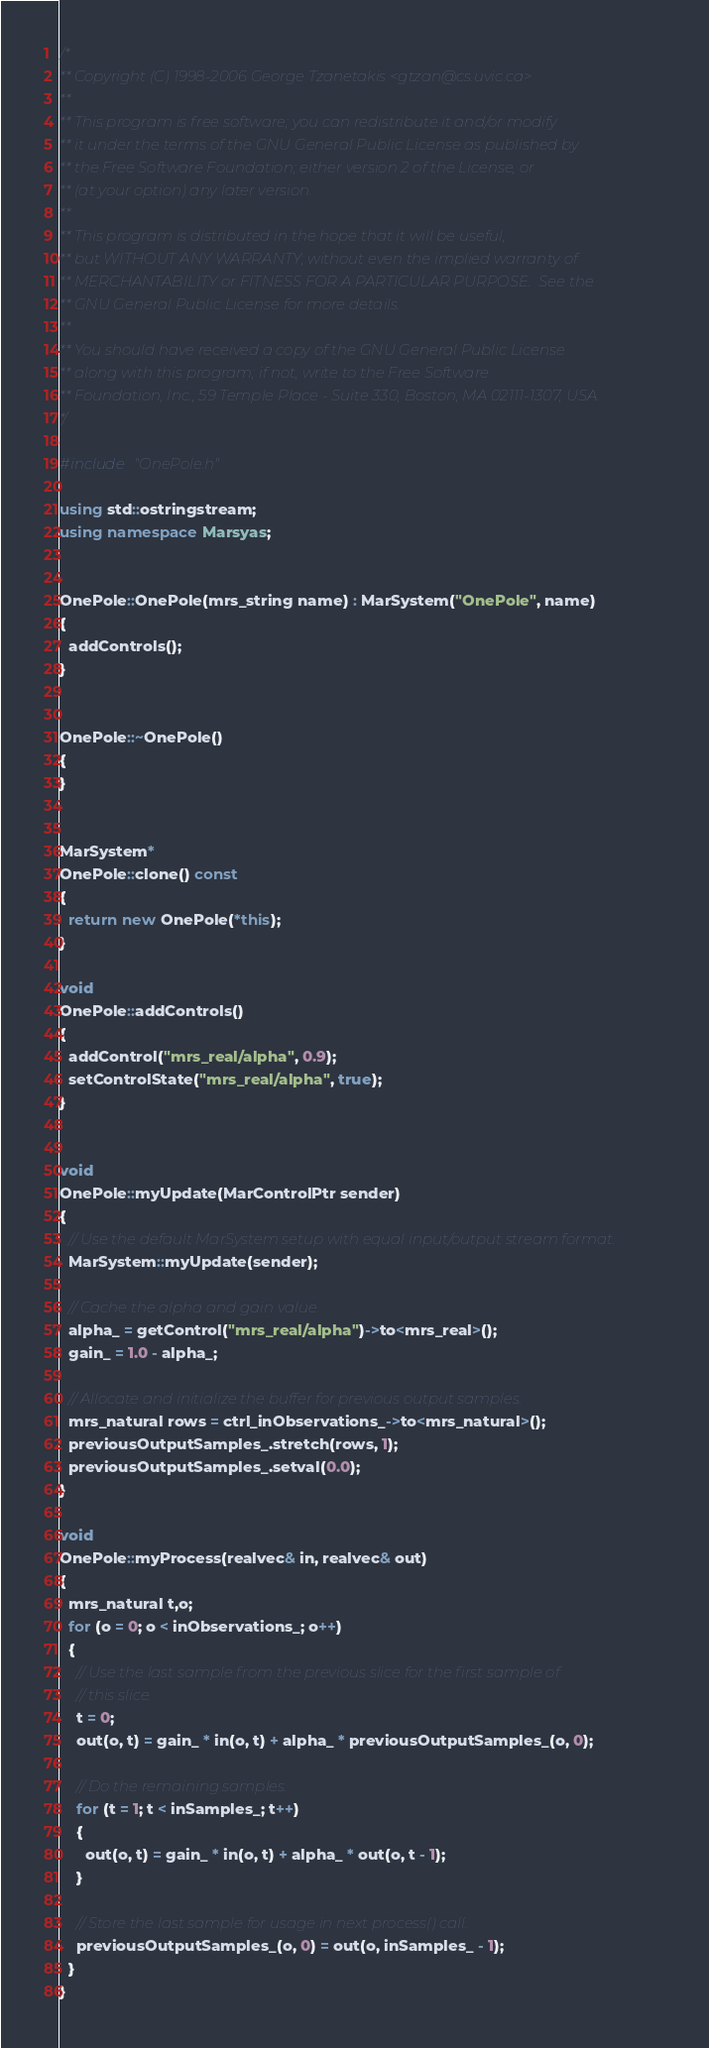<code> <loc_0><loc_0><loc_500><loc_500><_C++_>/*
** Copyright (C) 1998-2006 George Tzanetakis <gtzan@cs.uvic.ca>
**
** This program is free software; you can redistribute it and/or modify
** it under the terms of the GNU General Public License as published by
** the Free Software Foundation; either version 2 of the License, or
** (at your option) any later version.
**
** This program is distributed in the hope that it will be useful,
** but WITHOUT ANY WARRANTY; without even the implied warranty of
** MERCHANTABILITY or FITNESS FOR A PARTICULAR PURPOSE.  See the
** GNU General Public License for more details.
**
** You should have received a copy of the GNU General Public License
** along with this program; if not, write to the Free Software
** Foundation, Inc., 59 Temple Place - Suite 330, Boston, MA 02111-1307, USA.
*/

#include "OnePole.h"

using std::ostringstream;
using namespace Marsyas;


OnePole::OnePole(mrs_string name) : MarSystem("OnePole", name)
{
  addControls();
}


OnePole::~OnePole()
{
}


MarSystem*
OnePole::clone() const
{
  return new OnePole(*this);
}

void
OnePole::addControls()
{
  addControl("mrs_real/alpha", 0.9);
  setControlState("mrs_real/alpha", true);
}


void
OnePole::myUpdate(MarControlPtr sender)
{
  // Use the default MarSystem setup with equal input/output stream format.
  MarSystem::myUpdate(sender);

  // Cache the alpha and gain value.
  alpha_ = getControl("mrs_real/alpha")->to<mrs_real>();
  gain_ = 1.0 - alpha_;

  // Allocate and initialize the buffer for previous output samples.
  mrs_natural rows = ctrl_inObservations_->to<mrs_natural>();
  previousOutputSamples_.stretch(rows, 1);
  previousOutputSamples_.setval(0.0);
}

void
OnePole::myProcess(realvec& in, realvec& out)
{
  mrs_natural t,o;
  for (o = 0; o < inObservations_; o++)
  {
    // Use the last sample from the previous slice for the first sample of
    // this slice.
    t = 0;
    out(o, t) = gain_ * in(o, t) + alpha_ * previousOutputSamples_(o, 0);

    // Do the remaining samples.
    for (t = 1; t < inSamples_; t++)
    {
      out(o, t) = gain_ * in(o, t) + alpha_ * out(o, t - 1);
    }

    // Store the last sample for usage in next process() call.
    previousOutputSamples_(o, 0) = out(o, inSamples_ - 1);
  }
}
</code> 